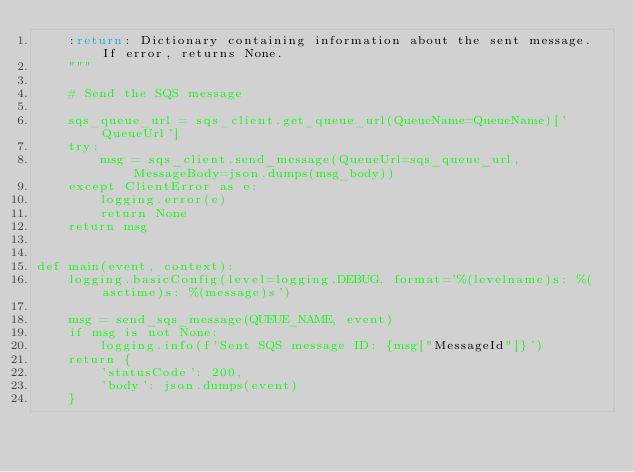Convert code to text. <code><loc_0><loc_0><loc_500><loc_500><_Python_>    :return: Dictionary containing information about the sent message. If error, returns None.
    """

    # Send the SQS message
    
    sqs_queue_url = sqs_client.get_queue_url(QueueName=QueueName)['QueueUrl']
    try:
        msg = sqs_client.send_message(QueueUrl=sqs_queue_url, MessageBody=json.dumps(msg_body))
    except ClientError as e:
        logging.error(e)
        return None
    return msg


def main(event, context):
    logging.basicConfig(level=logging.DEBUG, format='%(levelname)s: %(asctime)s: %(message)s')

    msg = send_sqs_message(QUEUE_NAME, event)
    if msg is not None:
        logging.info(f'Sent SQS message ID: {msg["MessageId"]}')
    return {
        'statusCode': 200,
        'body': json.dumps(event)
    }</code> 